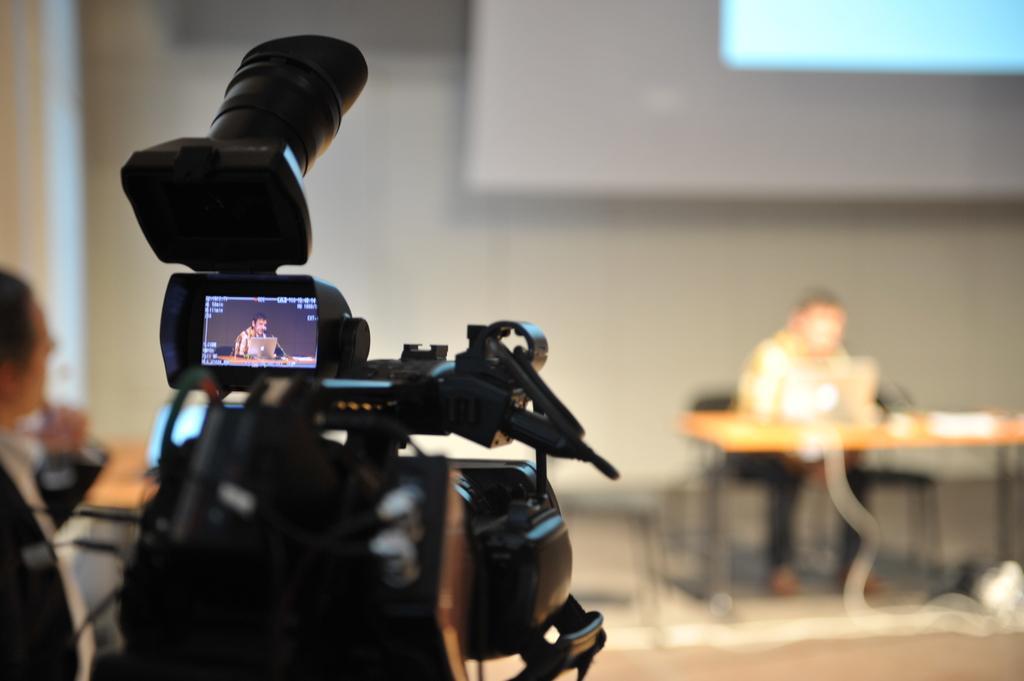Can you describe this image briefly? In this image we can see the camera. We can also see the person on the left. The background is blurred with a display screen, wall and a person sitting on the chair in front of the wooden table. 